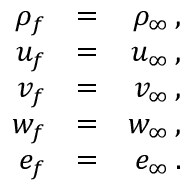<formula> <loc_0><loc_0><loc_500><loc_500>\begin{array} { r l r } { \rho _ { f } } & { = } & { \rho _ { \infty } \, , } \\ { u _ { f } } & { = } & { u _ { \infty } \, , } \\ { v _ { f } } & { = } & { v _ { \infty } \, , } \\ { w _ { f } } & { = } & { w _ { \infty } \, , } \\ { e _ { f } } & { = } & { e _ { \infty } \, . } \end{array}</formula> 